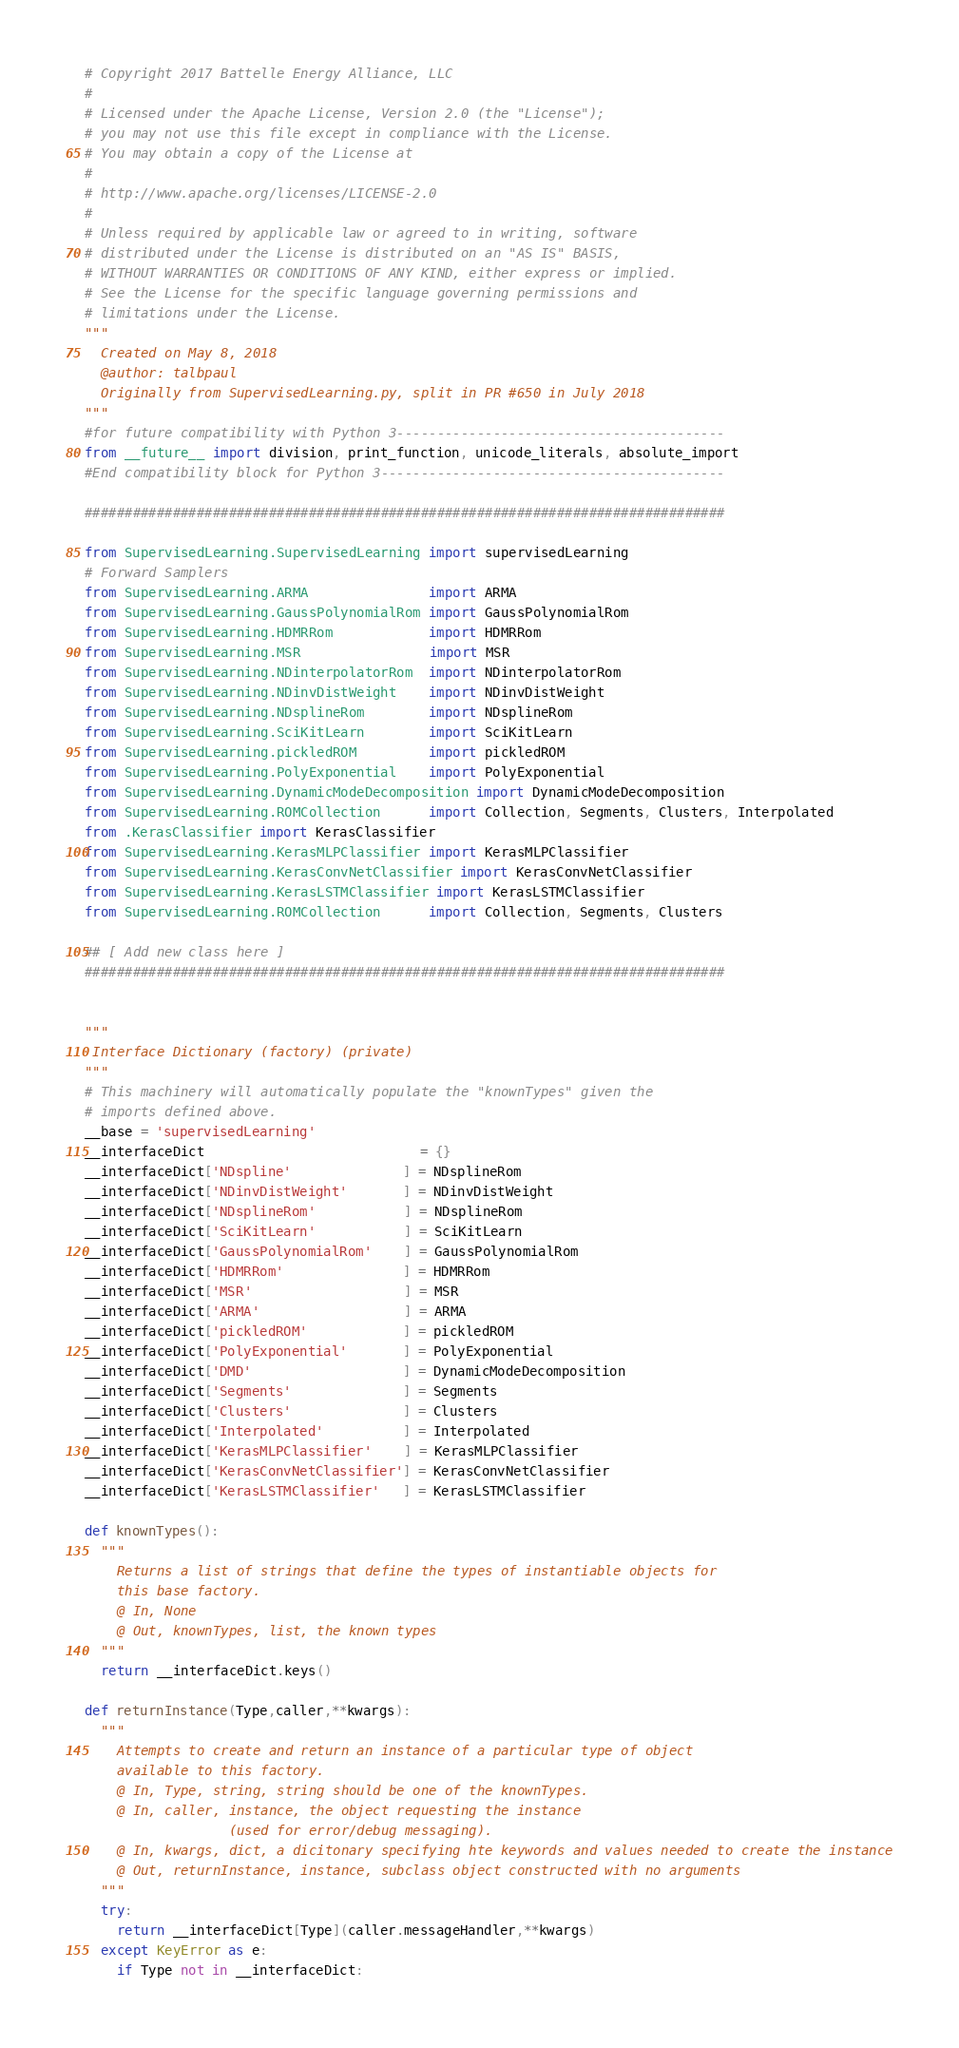<code> <loc_0><loc_0><loc_500><loc_500><_Python_># Copyright 2017 Battelle Energy Alliance, LLC
#
# Licensed under the Apache License, Version 2.0 (the "License");
# you may not use this file except in compliance with the License.
# You may obtain a copy of the License at
#
# http://www.apache.org/licenses/LICENSE-2.0
#
# Unless required by applicable law or agreed to in writing, software
# distributed under the License is distributed on an "AS IS" BASIS,
# WITHOUT WARRANTIES OR CONDITIONS OF ANY KIND, either express or implied.
# See the License for the specific language governing permissions and
# limitations under the License.
"""
  Created on May 8, 2018
  @author: talbpaul
  Originally from SupervisedLearning.py, split in PR #650 in July 2018
"""
#for future compatibility with Python 3-----------------------------------------
from __future__ import division, print_function, unicode_literals, absolute_import
#End compatibility block for Python 3-------------------------------------------

################################################################################

from SupervisedLearning.SupervisedLearning import supervisedLearning
# Forward Samplers
from SupervisedLearning.ARMA               import ARMA
from SupervisedLearning.GaussPolynomialRom import GaussPolynomialRom
from SupervisedLearning.HDMRRom            import HDMRRom
from SupervisedLearning.MSR                import MSR
from SupervisedLearning.NDinterpolatorRom  import NDinterpolatorRom
from SupervisedLearning.NDinvDistWeight    import NDinvDistWeight
from SupervisedLearning.NDsplineRom        import NDsplineRom
from SupervisedLearning.SciKitLearn        import SciKitLearn
from SupervisedLearning.pickledROM         import pickledROM
from SupervisedLearning.PolyExponential    import PolyExponential
from SupervisedLearning.DynamicModeDecomposition import DynamicModeDecomposition
from SupervisedLearning.ROMCollection      import Collection, Segments, Clusters, Interpolated
from .KerasClassifier import KerasClassifier
from SupervisedLearning.KerasMLPClassifier import KerasMLPClassifier
from SupervisedLearning.KerasConvNetClassifier import KerasConvNetClassifier
from SupervisedLearning.KerasLSTMClassifier import KerasLSTMClassifier
from SupervisedLearning.ROMCollection      import Collection, Segments, Clusters

## [ Add new class here ]
################################################################################


"""
 Interface Dictionary (factory) (private)
"""
# This machinery will automatically populate the "knownTypes" given the
# imports defined above.
__base = 'supervisedLearning'
__interfaceDict                           = {}
__interfaceDict['NDspline'              ] = NDsplineRom
__interfaceDict['NDinvDistWeight'       ] = NDinvDistWeight
__interfaceDict['NDsplineRom'           ] = NDsplineRom
__interfaceDict['SciKitLearn'           ] = SciKitLearn
__interfaceDict['GaussPolynomialRom'    ] = GaussPolynomialRom
__interfaceDict['HDMRRom'               ] = HDMRRom
__interfaceDict['MSR'                   ] = MSR
__interfaceDict['ARMA'                  ] = ARMA
__interfaceDict['pickledROM'            ] = pickledROM
__interfaceDict['PolyExponential'       ] = PolyExponential
__interfaceDict['DMD'                   ] = DynamicModeDecomposition
__interfaceDict['Segments'              ] = Segments
__interfaceDict['Clusters'              ] = Clusters
__interfaceDict['Interpolated'          ] = Interpolated
__interfaceDict['KerasMLPClassifier'    ] = KerasMLPClassifier
__interfaceDict['KerasConvNetClassifier'] = KerasConvNetClassifier
__interfaceDict['KerasLSTMClassifier'   ] = KerasLSTMClassifier

def knownTypes():
  """
    Returns a list of strings that define the types of instantiable objects for
    this base factory.
    @ In, None
    @ Out, knownTypes, list, the known types
  """
  return __interfaceDict.keys()

def returnInstance(Type,caller,**kwargs):
  """
    Attempts to create and return an instance of a particular type of object
    available to this factory.
    @ In, Type, string, string should be one of the knownTypes.
    @ In, caller, instance, the object requesting the instance
                  (used for error/debug messaging).
    @ In, kwargs, dict, a dicitonary specifying hte keywords and values needed to create the instance
    @ Out, returnInstance, instance, subclass object constructed with no arguments
  """
  try:
    return __interfaceDict[Type](caller.messageHandler,**kwargs)
  except KeyError as e:
    if Type not in __interfaceDict:</code> 